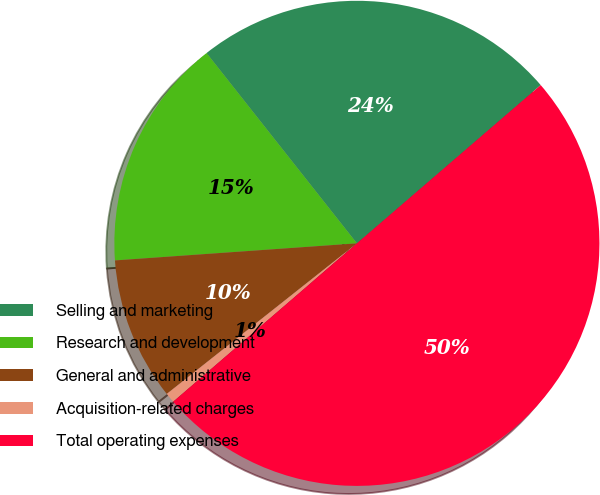Convert chart to OTSL. <chart><loc_0><loc_0><loc_500><loc_500><pie_chart><fcel>Selling and marketing<fcel>Research and development<fcel>General and administrative<fcel>Acquisition-related charges<fcel>Total operating expenses<nl><fcel>24.33%<fcel>15.48%<fcel>9.54%<fcel>0.66%<fcel>50.0%<nl></chart> 